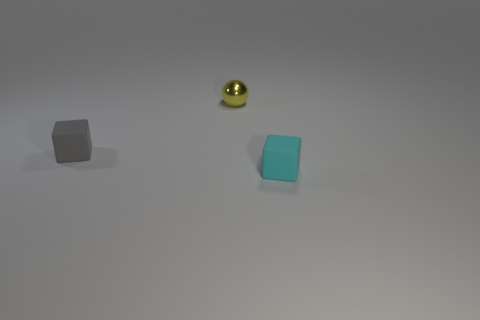Add 1 yellow things. How many objects exist? 4 Subtract 0 blue balls. How many objects are left? 3 Subtract all spheres. How many objects are left? 2 Subtract all gray rubber objects. Subtract all cubes. How many objects are left? 0 Add 2 tiny cyan matte things. How many tiny cyan matte things are left? 3 Add 1 cyan matte cubes. How many cyan matte cubes exist? 2 